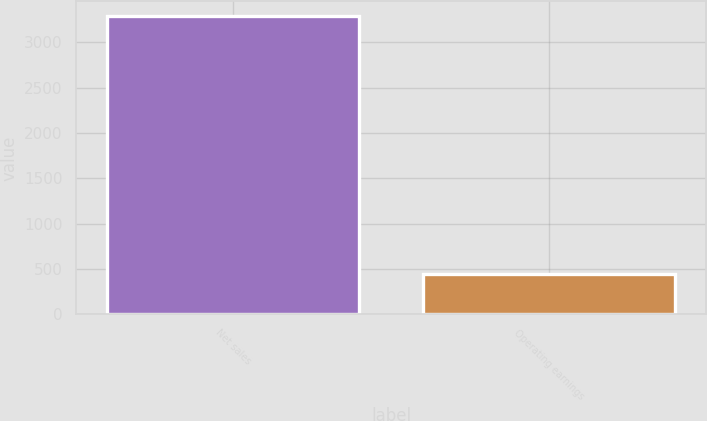<chart> <loc_0><loc_0><loc_500><loc_500><bar_chart><fcel>Net sales<fcel>Operating earnings<nl><fcel>3289<fcel>447<nl></chart> 